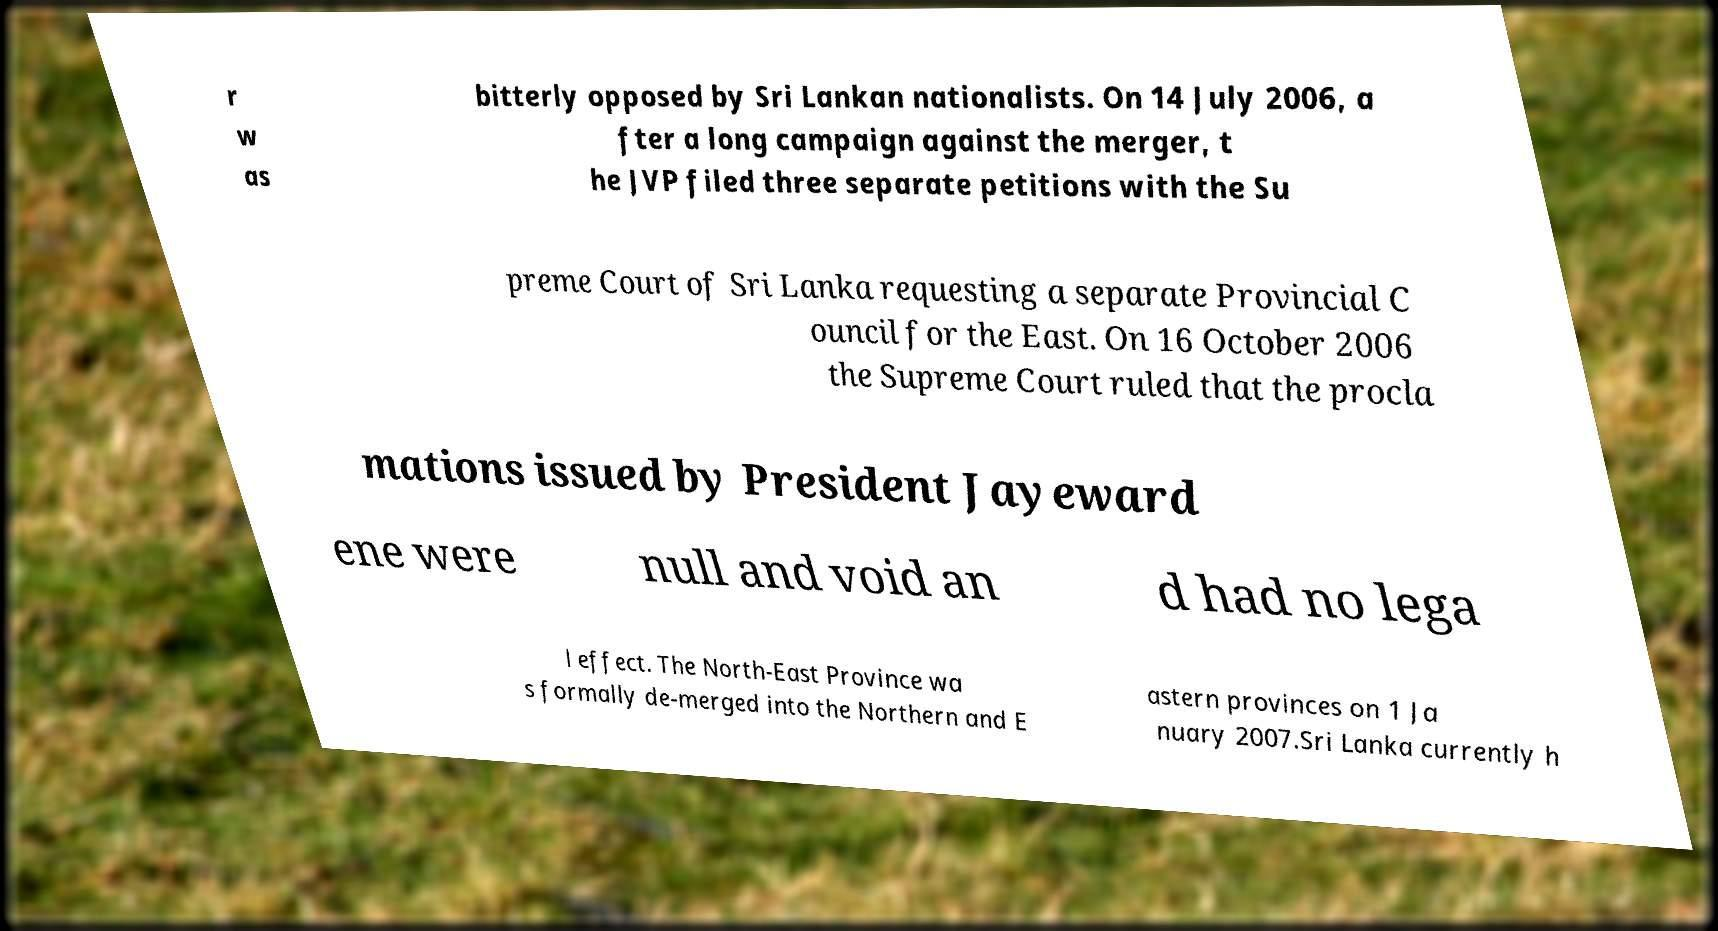For documentation purposes, I need the text within this image transcribed. Could you provide that? r w as bitterly opposed by Sri Lankan nationalists. On 14 July 2006, a fter a long campaign against the merger, t he JVP filed three separate petitions with the Su preme Court of Sri Lanka requesting a separate Provincial C ouncil for the East. On 16 October 2006 the Supreme Court ruled that the procla mations issued by President Jayeward ene were null and void an d had no lega l effect. The North-East Province wa s formally de-merged into the Northern and E astern provinces on 1 Ja nuary 2007.Sri Lanka currently h 